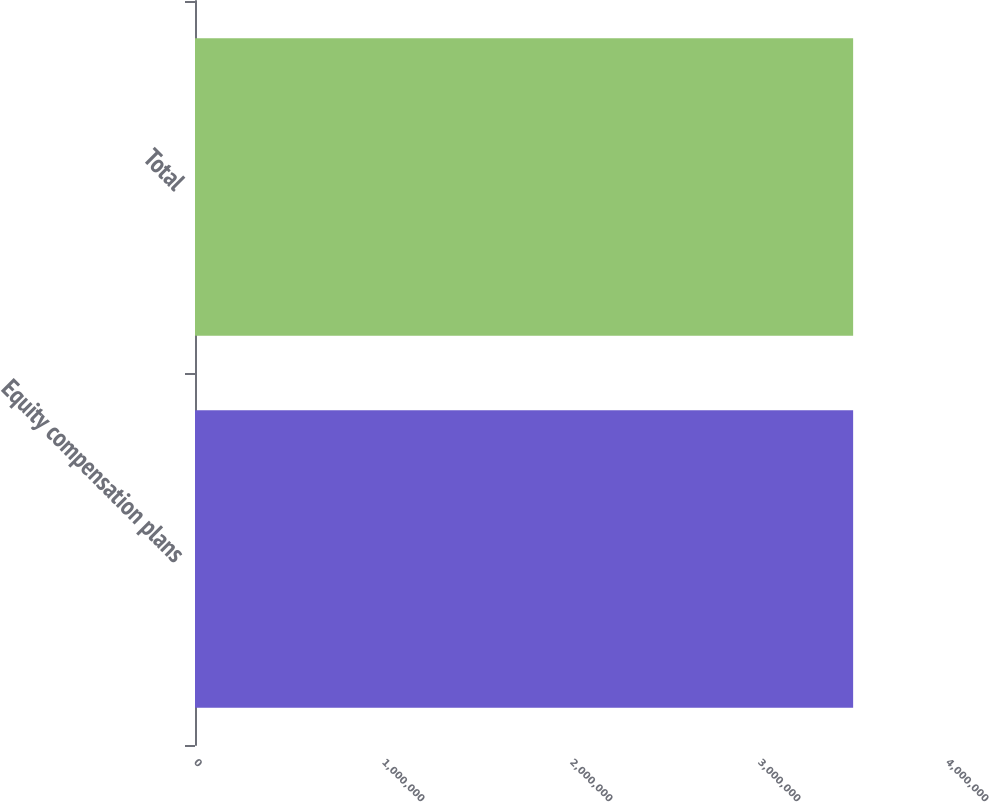<chart> <loc_0><loc_0><loc_500><loc_500><bar_chart><fcel>Equity compensation plans<fcel>Total<nl><fcel>3.50072e+06<fcel>3.50072e+06<nl></chart> 